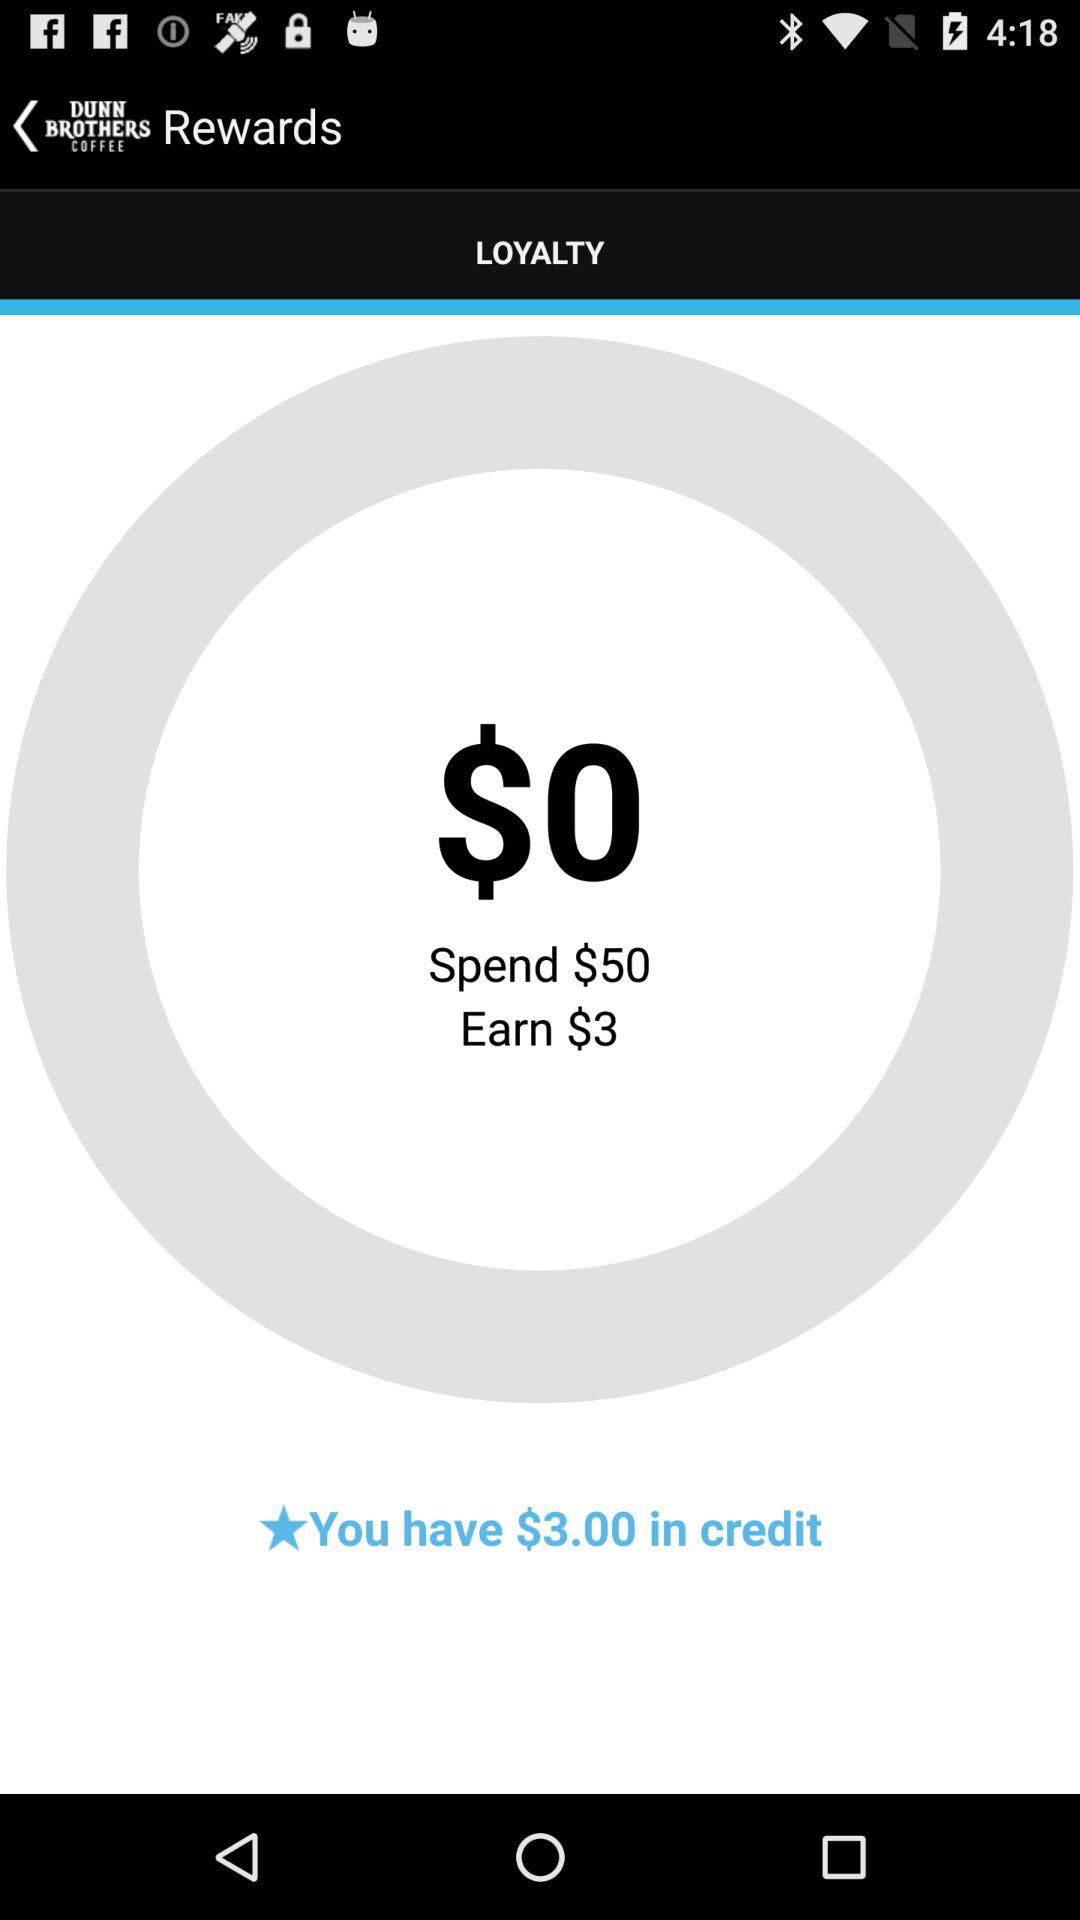How much more money do I need to spend to earn $3 in rewards?
Answer the question using a single word or phrase. 50 